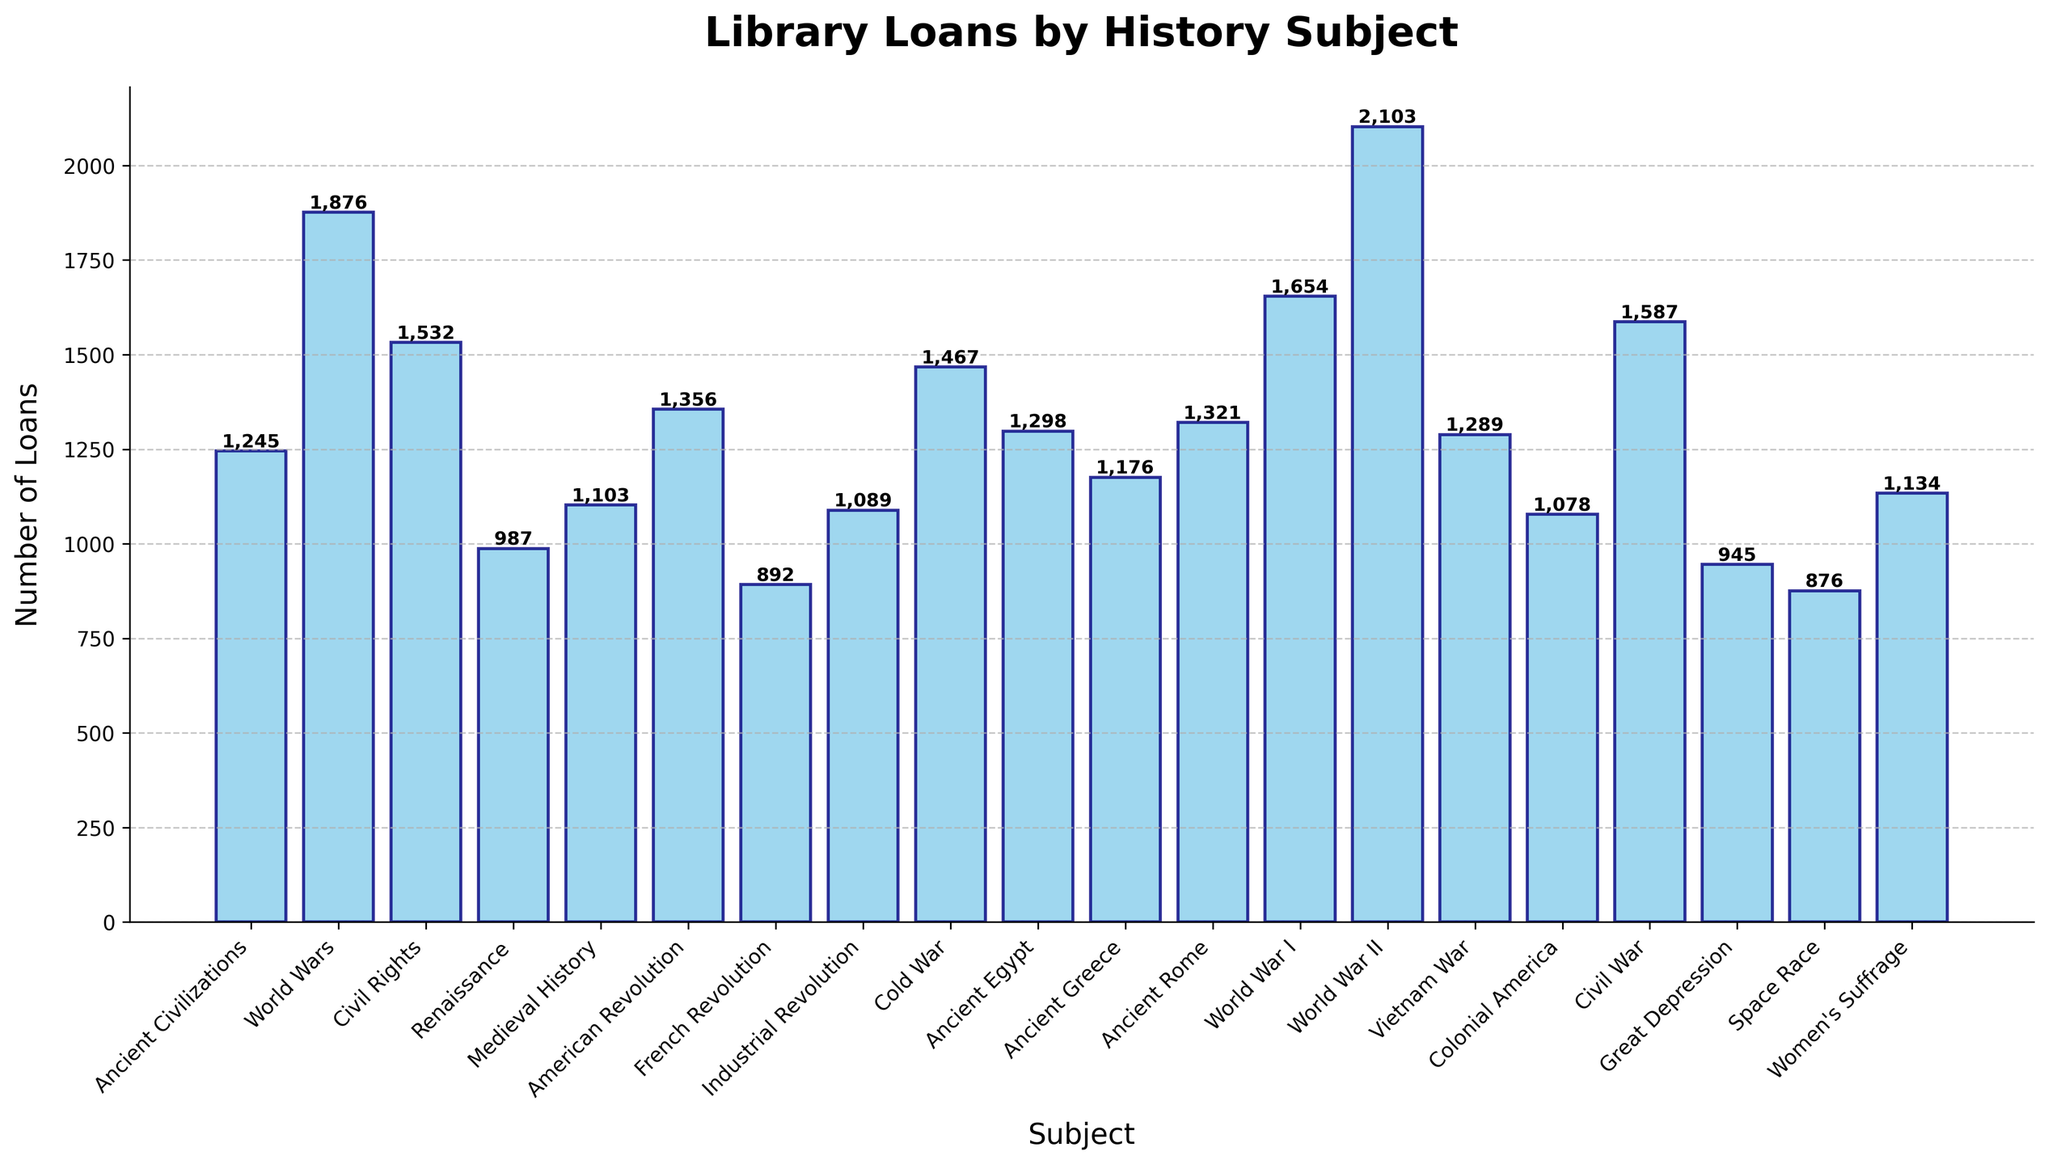What subject had the highest number of loans? To find the subject with the highest number of loans, look for the tallest bar in the chart.
Answer: World War II What subjects had fewer loans than the Civil Rights? Compare the height of the bar for Civil Rights with others to identify those that are shorter.
Answer: Renaissance, Medieval History, French Revolution, Industrial Revolution, Colonial America, Great Depression, Space Race, Women's Suffrage What is the combined total of loans for World War I and World War II? Identify the loans for both World War I (1654) and World War II (2103), then add them together: 1654 + 2103
Answer: 3757 Which had more loans, Ancient Egypt or Ancient Greece? Compare the height of the bar for Ancient Egypt (1298) with Ancient Greece (1176).
Answer: Ancient Egypt What is the difference in loans between the American Revolution and the Renaissance? Identify the loans for both the American Revolution (1356) and Renaissance (987), then subtract the smaller from the larger: 1356 - 987
Answer: 369 What is the average number of loans across all subjects? Add the number of loans for all subjects and divide by the number of subjects: (1245 + 1876 + 1532 + 987 + 1103 + 1356 + 892 + 1089 + 1467 + 1298 + 1176 + 1321 + 1654 + 2103 + 1289 + 1078 + 1587 + 945 + 876 + 1134) / 20.
Answer: 1286.35 How many history subjects have loans greater than 1500? Count the number of bars with height greater than 1500: World Wars, Civil Rights, World War I, World War II, Civil War.
Answer: 5 If you sum the loans for Medieval History, Colonial America, and the Great Depression, what is the total? Identify the loans for Medieval History (1103), Colonial America (1078), and Great Depression (945), and sum them: 1103 + 1078 + 945.
Answer: 3126 What subject has the second highest number of loans? Identify the two tallest bars, the tallest is World War II, hence the second tallest is World Wars.
Answer: World Wars How many loans separate the Cold War from the Vietnam War? Identify the loans for Cold War (1467) and Vietnam War (1289), then subtract the smaller from the larger: 1467 - 1289.
Answer: 178 